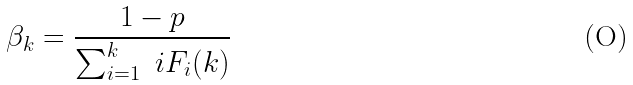<formula> <loc_0><loc_0><loc_500><loc_500>\beta _ { k } = \frac { 1 - p } { \sum _ { i = 1 } ^ { k } \ i F _ { i } ( k ) }</formula> 